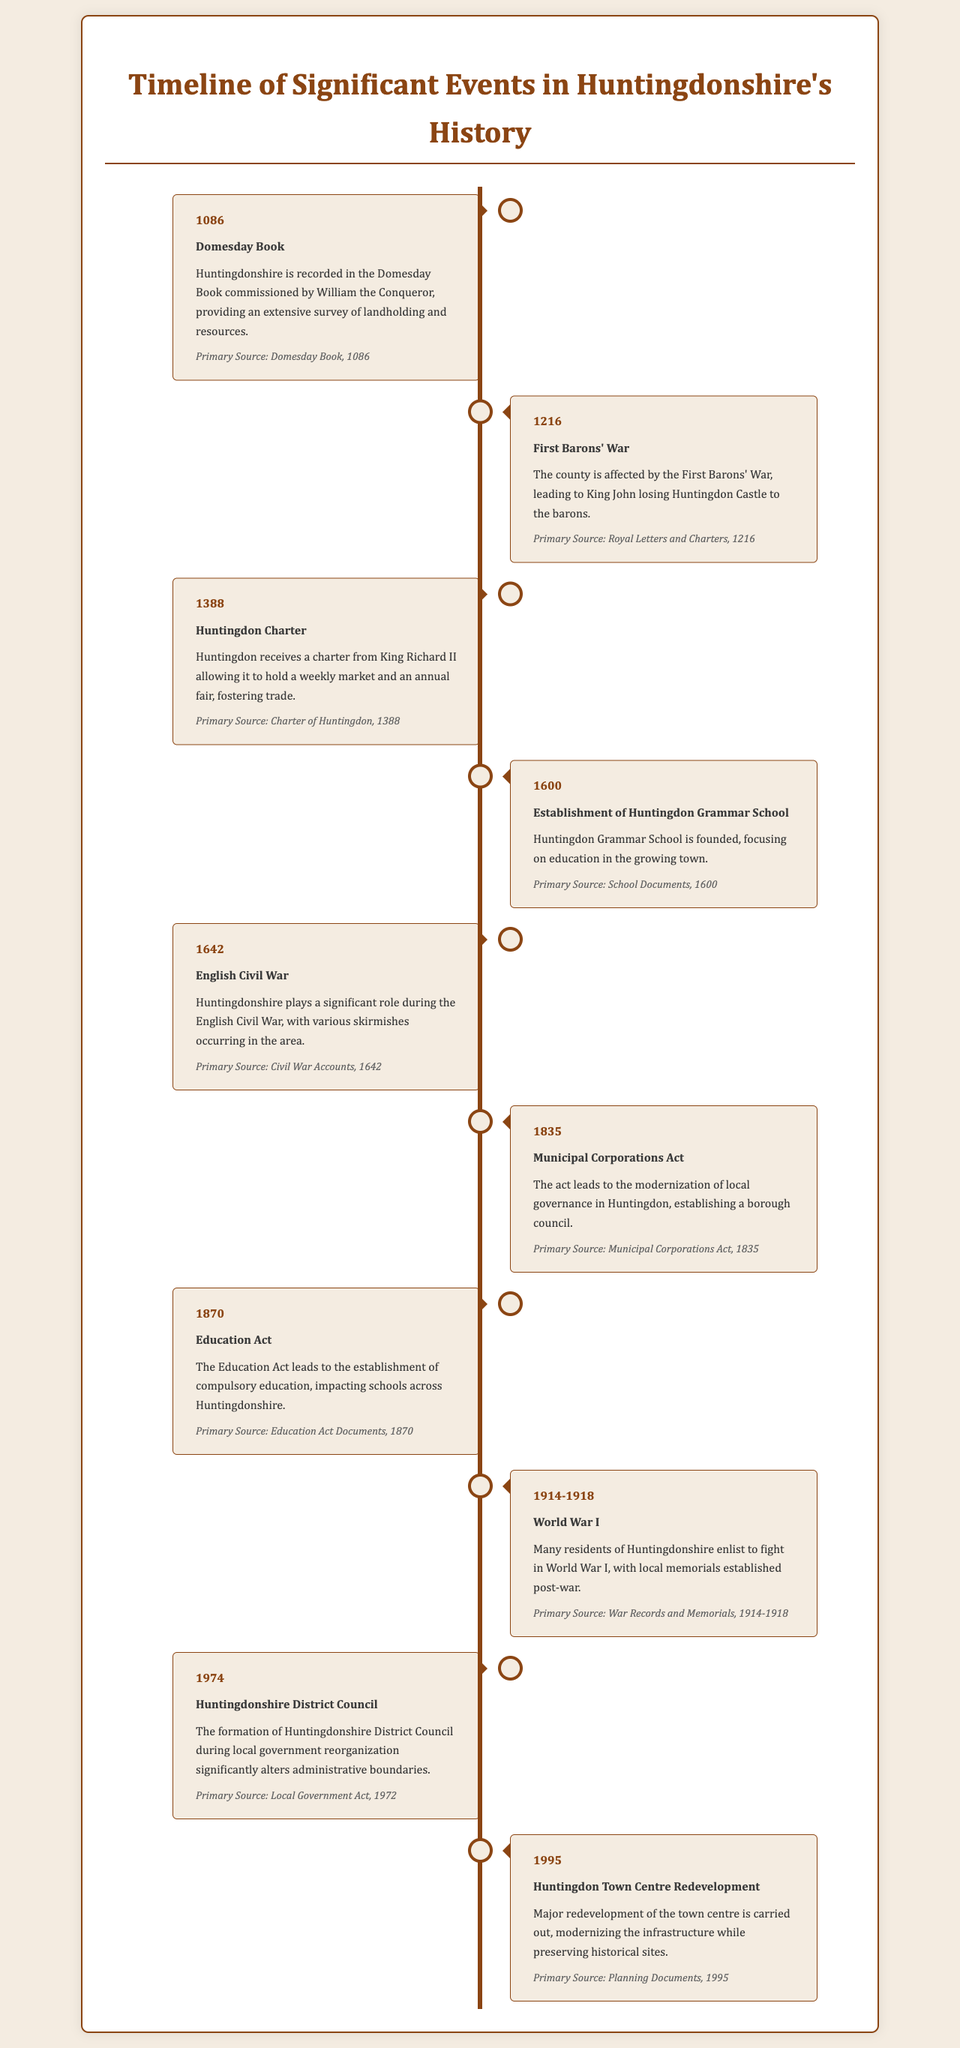What year was the Domesday Book commissioned? The document states that the Domesday Book was recorded in 1086.
Answer: 1086 Which significant event occurred in 1216? The document mentions that the First Barons' War affected the county in 1216.
Answer: First Barons' War What charter was received in 1388? The timeline notes that Huntingdon received a charter to hold a weekly market and an annual fair in 1388.
Answer: Huntingdon Charter What educational institution was established in 1600? The document states that Huntingdon Grammar School was founded in 1600.
Answer: Huntingdon Grammar School What major conflict occurred in 1642? According to the document, the English Civil War was significant in 1642.
Answer: English Civil War Which act modernized local governance in 1835? The Municipal Corporations Act led to the modernization of local governance in Huntingdon in 1835.
Answer: Municipal Corporations Act How did the 1870 Education Act impact Huntingdonshire? The document explains that the Education Act led to the establishment of compulsory education in Huntingdonshire.
Answer: Compulsory education What were Huntingdonshire residents involved in from 1914 to 1918? The document emphasizes that many residents enlisted to fight in World War I during this period.
Answer: World War I What major change occurred in 1974 regarding local governance? The document states that Huntingdonshire District Council was formed in 1974, changing administrative boundaries.
Answer: Huntingdonshire District Council What significant redevelopment occurred in Huntingdon in 1995? The timeline notes that there was a major redevelopment of the town centre carried out in 1995.
Answer: Town centre redevelopment 